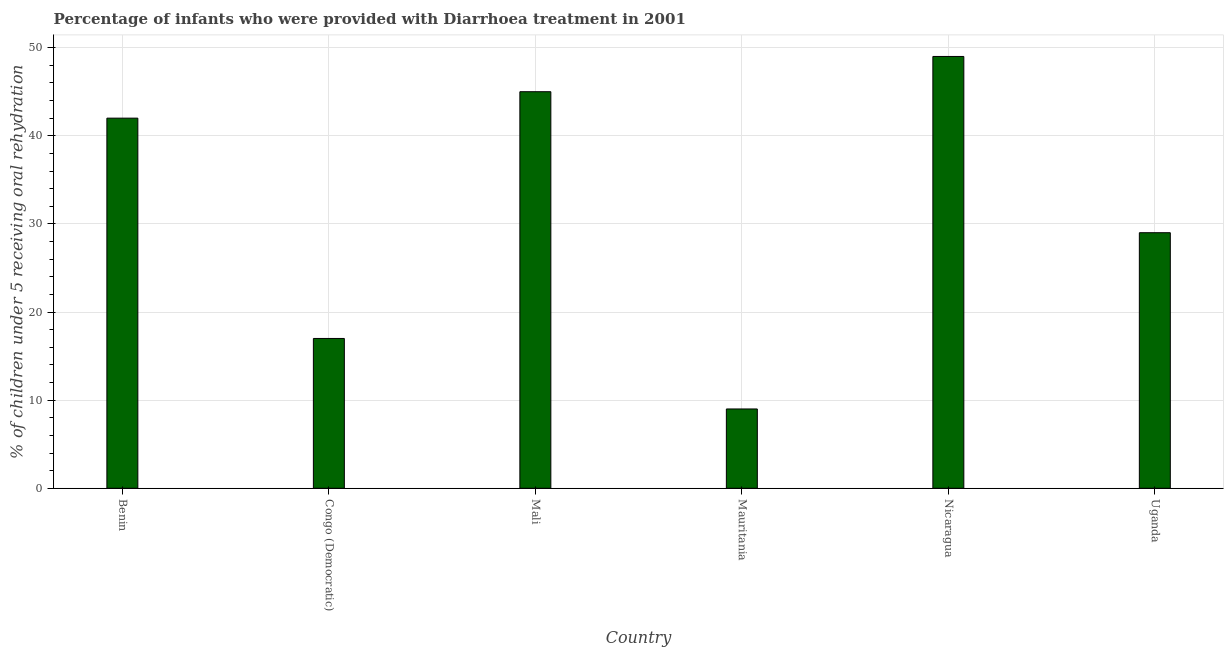Does the graph contain any zero values?
Provide a short and direct response. No. Does the graph contain grids?
Your answer should be compact. Yes. What is the title of the graph?
Give a very brief answer. Percentage of infants who were provided with Diarrhoea treatment in 2001. What is the label or title of the X-axis?
Ensure brevity in your answer.  Country. What is the label or title of the Y-axis?
Make the answer very short. % of children under 5 receiving oral rehydration. Across all countries, what is the maximum percentage of children who were provided with treatment diarrhoea?
Your response must be concise. 49. Across all countries, what is the minimum percentage of children who were provided with treatment diarrhoea?
Your response must be concise. 9. In which country was the percentage of children who were provided with treatment diarrhoea maximum?
Offer a very short reply. Nicaragua. In which country was the percentage of children who were provided with treatment diarrhoea minimum?
Your answer should be very brief. Mauritania. What is the sum of the percentage of children who were provided with treatment diarrhoea?
Provide a succinct answer. 191. What is the difference between the percentage of children who were provided with treatment diarrhoea in Benin and Congo (Democratic)?
Ensure brevity in your answer.  25. What is the average percentage of children who were provided with treatment diarrhoea per country?
Make the answer very short. 31. What is the median percentage of children who were provided with treatment diarrhoea?
Make the answer very short. 35.5. What is the ratio of the percentage of children who were provided with treatment diarrhoea in Mali to that in Nicaragua?
Ensure brevity in your answer.  0.92. Is the percentage of children who were provided with treatment diarrhoea in Congo (Democratic) less than that in Nicaragua?
Ensure brevity in your answer.  Yes. Is the difference between the percentage of children who were provided with treatment diarrhoea in Mali and Mauritania greater than the difference between any two countries?
Ensure brevity in your answer.  No. Is the sum of the percentage of children who were provided with treatment diarrhoea in Benin and Congo (Democratic) greater than the maximum percentage of children who were provided with treatment diarrhoea across all countries?
Keep it short and to the point. Yes. How many bars are there?
Your answer should be very brief. 6. What is the difference between two consecutive major ticks on the Y-axis?
Your answer should be compact. 10. Are the values on the major ticks of Y-axis written in scientific E-notation?
Give a very brief answer. No. What is the % of children under 5 receiving oral rehydration in Benin?
Give a very brief answer. 42. What is the % of children under 5 receiving oral rehydration in Mali?
Offer a terse response. 45. What is the difference between the % of children under 5 receiving oral rehydration in Benin and Congo (Democratic)?
Your answer should be very brief. 25. What is the difference between the % of children under 5 receiving oral rehydration in Benin and Mali?
Offer a very short reply. -3. What is the difference between the % of children under 5 receiving oral rehydration in Benin and Mauritania?
Ensure brevity in your answer.  33. What is the difference between the % of children under 5 receiving oral rehydration in Benin and Nicaragua?
Keep it short and to the point. -7. What is the difference between the % of children under 5 receiving oral rehydration in Benin and Uganda?
Your response must be concise. 13. What is the difference between the % of children under 5 receiving oral rehydration in Congo (Democratic) and Mauritania?
Keep it short and to the point. 8. What is the difference between the % of children under 5 receiving oral rehydration in Congo (Democratic) and Nicaragua?
Keep it short and to the point. -32. What is the difference between the % of children under 5 receiving oral rehydration in Mali and Mauritania?
Your response must be concise. 36. What is the difference between the % of children under 5 receiving oral rehydration in Mali and Uganda?
Offer a terse response. 16. What is the difference between the % of children under 5 receiving oral rehydration in Mauritania and Uganda?
Keep it short and to the point. -20. What is the ratio of the % of children under 5 receiving oral rehydration in Benin to that in Congo (Democratic)?
Give a very brief answer. 2.47. What is the ratio of the % of children under 5 receiving oral rehydration in Benin to that in Mali?
Your answer should be very brief. 0.93. What is the ratio of the % of children under 5 receiving oral rehydration in Benin to that in Mauritania?
Make the answer very short. 4.67. What is the ratio of the % of children under 5 receiving oral rehydration in Benin to that in Nicaragua?
Provide a short and direct response. 0.86. What is the ratio of the % of children under 5 receiving oral rehydration in Benin to that in Uganda?
Ensure brevity in your answer.  1.45. What is the ratio of the % of children under 5 receiving oral rehydration in Congo (Democratic) to that in Mali?
Give a very brief answer. 0.38. What is the ratio of the % of children under 5 receiving oral rehydration in Congo (Democratic) to that in Mauritania?
Provide a short and direct response. 1.89. What is the ratio of the % of children under 5 receiving oral rehydration in Congo (Democratic) to that in Nicaragua?
Ensure brevity in your answer.  0.35. What is the ratio of the % of children under 5 receiving oral rehydration in Congo (Democratic) to that in Uganda?
Make the answer very short. 0.59. What is the ratio of the % of children under 5 receiving oral rehydration in Mali to that in Mauritania?
Provide a succinct answer. 5. What is the ratio of the % of children under 5 receiving oral rehydration in Mali to that in Nicaragua?
Make the answer very short. 0.92. What is the ratio of the % of children under 5 receiving oral rehydration in Mali to that in Uganda?
Make the answer very short. 1.55. What is the ratio of the % of children under 5 receiving oral rehydration in Mauritania to that in Nicaragua?
Your answer should be compact. 0.18. What is the ratio of the % of children under 5 receiving oral rehydration in Mauritania to that in Uganda?
Make the answer very short. 0.31. What is the ratio of the % of children under 5 receiving oral rehydration in Nicaragua to that in Uganda?
Your answer should be compact. 1.69. 